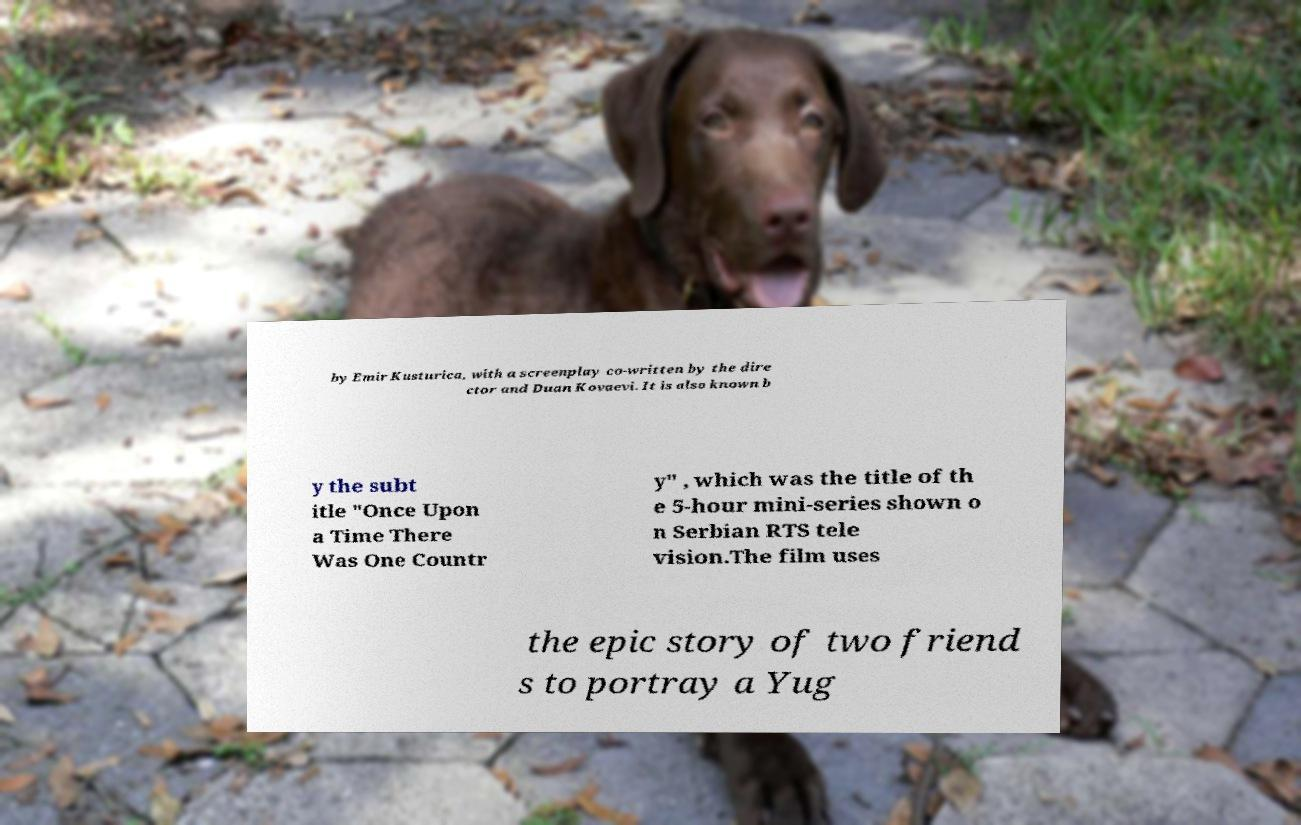Please read and relay the text visible in this image. What does it say? by Emir Kusturica, with a screenplay co-written by the dire ctor and Duan Kovaevi. It is also known b y the subt itle "Once Upon a Time There Was One Countr y" , which was the title of th e 5-hour mini-series shown o n Serbian RTS tele vision.The film uses the epic story of two friend s to portray a Yug 